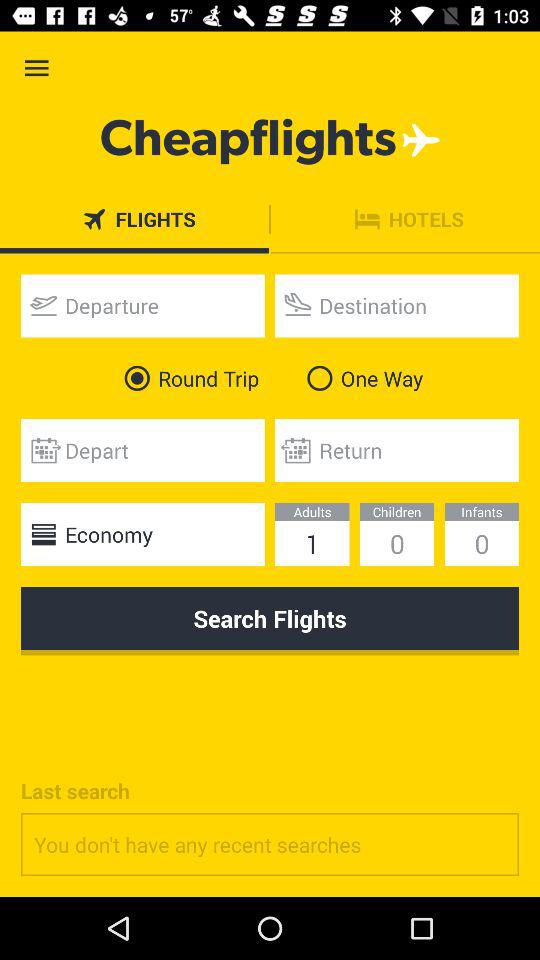How many more number of adults are there than children?
Answer the question using a single word or phrase. 1 